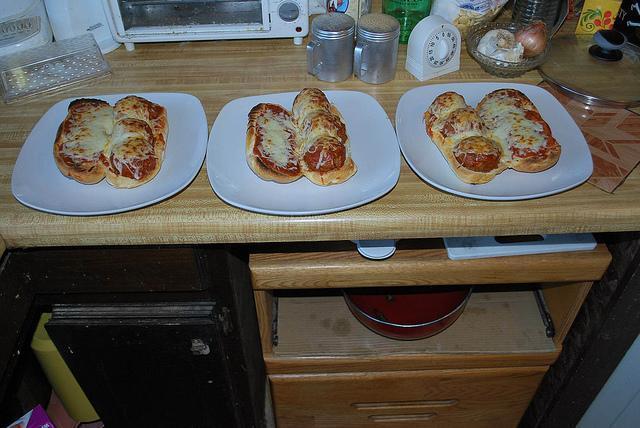How many plates have food?
Give a very brief answer. 3. How many sandwiches are visible?
Give a very brief answer. 3. How many bowls can be seen?
Give a very brief answer. 2. How many people are wearing purple shirt?
Give a very brief answer. 0. 